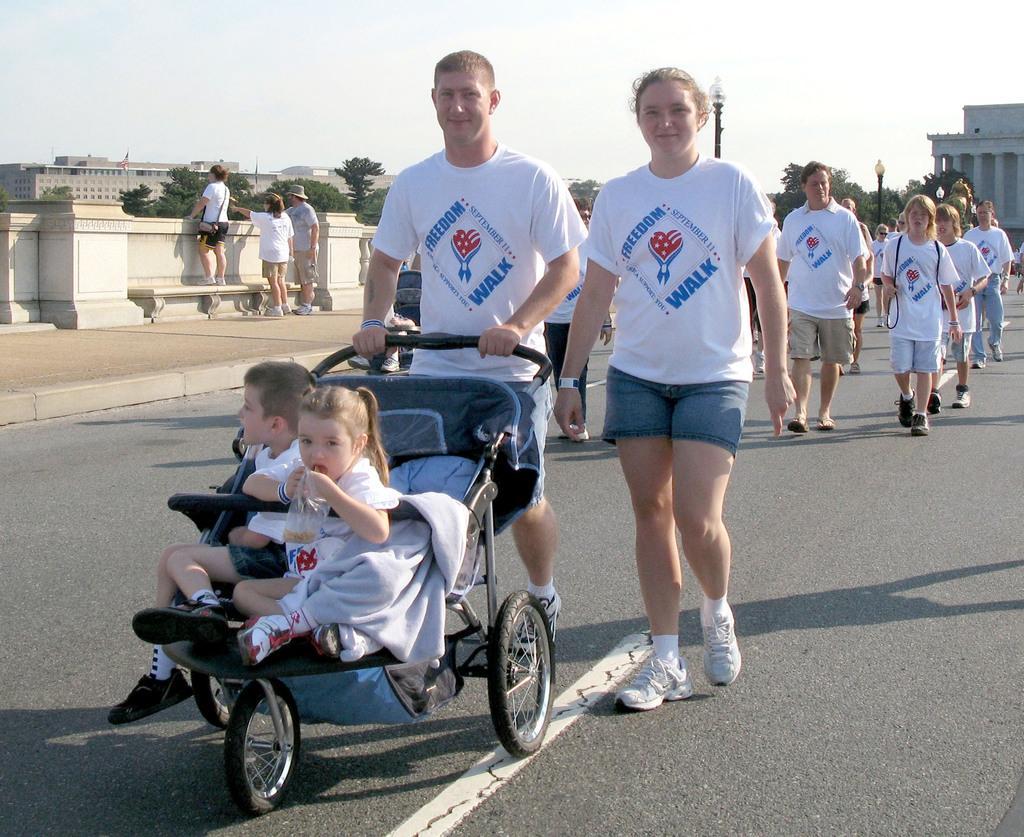How would you summarize this image in a sentence or two? In this picture I can see a boy and a girl sitting on the stroller. There are group of people standing and there is a person standing on the bench, and in the background there are buildings, trees, lights, poles and the sky. 